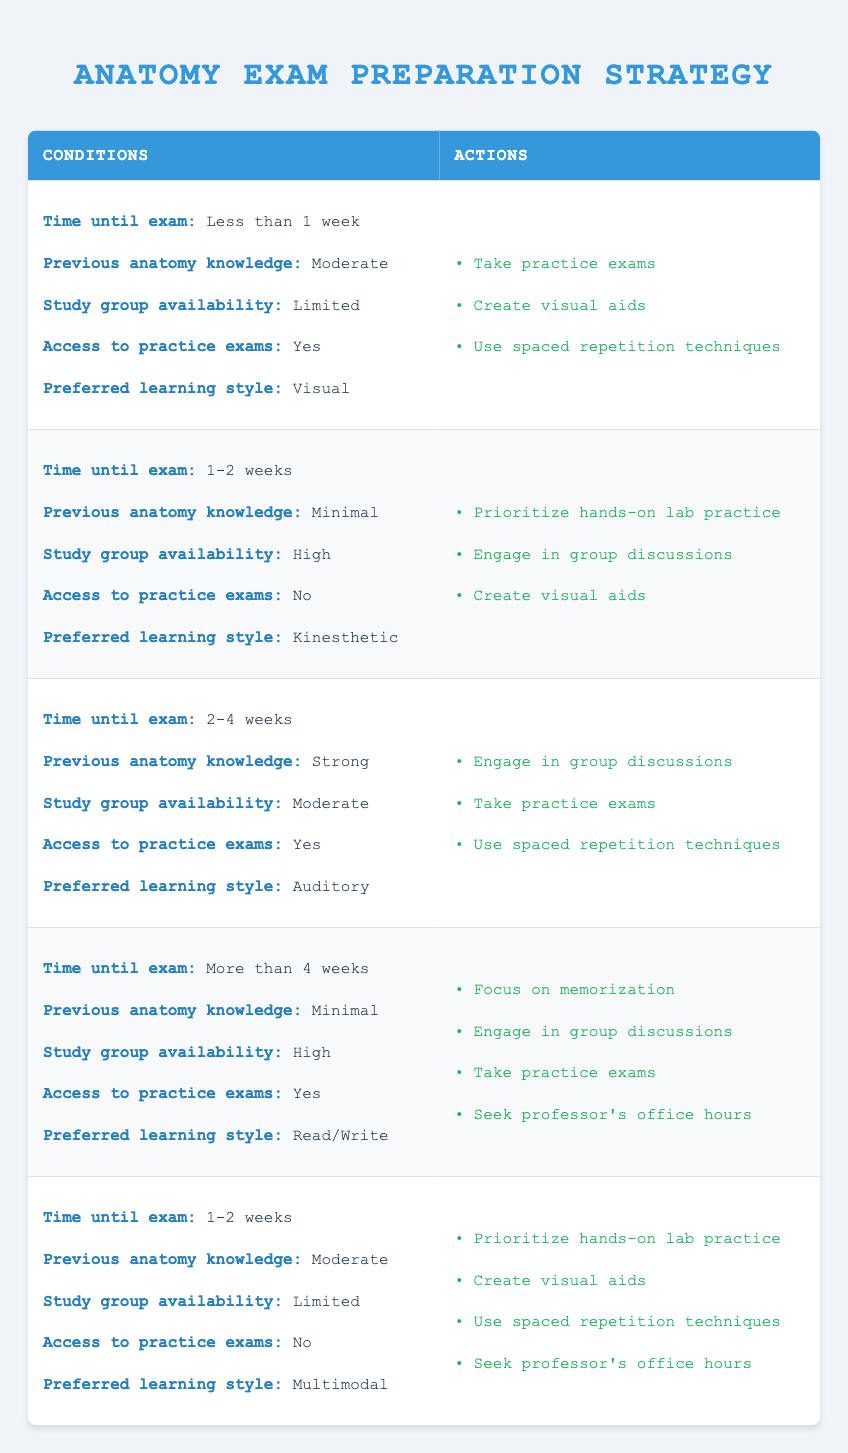What preparation strategies should I focus on if the exam is less than one week away, I have moderate prior anatomy knowledge, limited study group availability, have access to practice exams, and prefer visual learning? According to the table, under these conditions, the recommended strategies are to take practice exams, create visual aids, and use spaced repetition techniques.
Answer: Take practice exams, create visual aids, use spaced repetition techniques If the exam is scheduled for 1-2 weeks and my previous anatomy knowledge is strong, what actions can I take? The table does not provide any entries for 1-2 weeks with strong prior knowledge; therefore, it's necessary to analyze related conditions. The closest match shows that if previous knowledge is minimal, the focus should be on hands-on lab practice, engaging in group discussions, and creating visual aids. However, since there are no definitive actions for strong knowledge within this timeframe, no clear strategy can be inferred.
Answer: No clear strategy found Is it true that prioritizing hands-on lab practice is recommended when my previous anatomy knowledge is minimal and I have high study group availability? Yes, based on the table, if the exam is 1-2 weeks away, has minimal previous knowledge, high group availability, and no access to practice exams, hands-on lab practice is indeed recommended.
Answer: Yes What is the total number of actions recommended for the scenario where the exam is more than four weeks away, with minimal previous knowledge, high study group availability, access to practice exams, and a read/write learning style? The actions listed for this scenario include focusing on memorization, engaging in group discussions, taking practice exams, and seeking professor's office hours, making a total of four actions.
Answer: Four actions If I were to choose one study strategy for each scenario based on the highest urgency, which actions should I consider for the condition where the time until the exam is less than one week? With less than one week until the exam, the most urgent actions are to take practice exams, as they provide the most immediate assessment practice, and then create visual aids, followed by using spaced repetition techniques for efficient review.
Answer: Take practice exams In what situation should I focus on memorization regarding my anatomy exam preparation? Focusing on memorization should be considered when the exam is scheduled for more than four weeks away, and you have minimal previous anatomy knowledge, high study group availability, have access to practice exams, and prefer a read/write learning style.
Answer: More than four weeks with minimal prior knowledge Which learning style is linked to taking practice exams if previous knowledge is strong? The auditory learning style is linked to taking practice exams when there are 2-4 weeks until the exam, strong previous knowledge, moderate study group availability, and access to practice exams.
Answer: Auditory learning style Are there any actions to take if I have a multimodal learning style and 1-2 weeks until the exam with limited study group availability? Yes, in this scenario, you should prioritize hands-on lab practice, create visual aids, use spaced repetition techniques, and seek professor's office hours as your actions.
Answer: Yes 